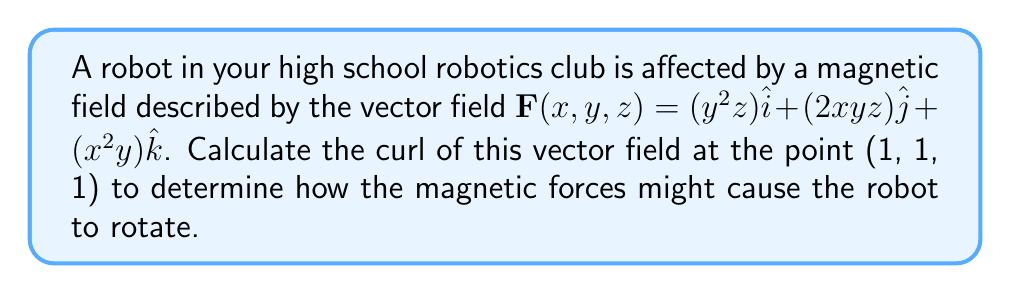Help me with this question. Let's break this down into simple steps:

1) The curl of a vector field $\mathbf{F}(x,y,z) = P\hat{i} + Q\hat{j} + R\hat{k}$ is given by:

   $$\text{curl}\,\mathbf{F} = \nabla \times \mathbf{F} = \left(\frac{\partial R}{\partial y} - \frac{\partial Q}{\partial z}\right)\hat{i} + \left(\frac{\partial P}{\partial z} - \frac{\partial R}{\partial x}\right)\hat{j} + \left(\frac{\partial Q}{\partial x} - \frac{\partial P}{\partial y}\right)\hat{k}$$

2) In our case:
   $P = y^2z$, $Q = 2xyz$, $R = x^2y$

3) Let's calculate each partial derivative:

   $\frac{\partial R}{\partial y} = x^2$
   $\frac{\partial Q}{\partial z} = 2xy$
   $\frac{\partial P}{\partial z} = y^2$
   $\frac{\partial R}{\partial x} = 2xy$
   $\frac{\partial Q}{\partial x} = 2yz$
   $\frac{\partial P}{\partial y} = 2yz$

4) Now, let's substitute these into our curl formula:

   $$\text{curl}\,\mathbf{F} = (x^2 - 2xy)\hat{i} + (y^2 - 2xy)\hat{j} + (2yz - 2yz)\hat{k}$$

5) Simplify:

   $$\text{curl}\,\mathbf{F} = (x^2 - 2xy)\hat{i} + (y^2 - 2xy)\hat{j} + 0\hat{k}$$

6) Now, we need to evaluate this at the point (1, 1, 1):

   $$\text{curl}\,\mathbf{F}(1,1,1) = (1^2 - 2(1)(1))\hat{i} + (1^2 - 2(1)(1))\hat{j} + 0\hat{k}$$
                                    $$= -1\hat{i} - 1\hat{j} + 0\hat{k}$$

This result shows how the magnetic field tends to rotate the robot around the x and y axes at the point (1, 1, 1).
Answer: $-\hat{i} - \hat{j}$ 